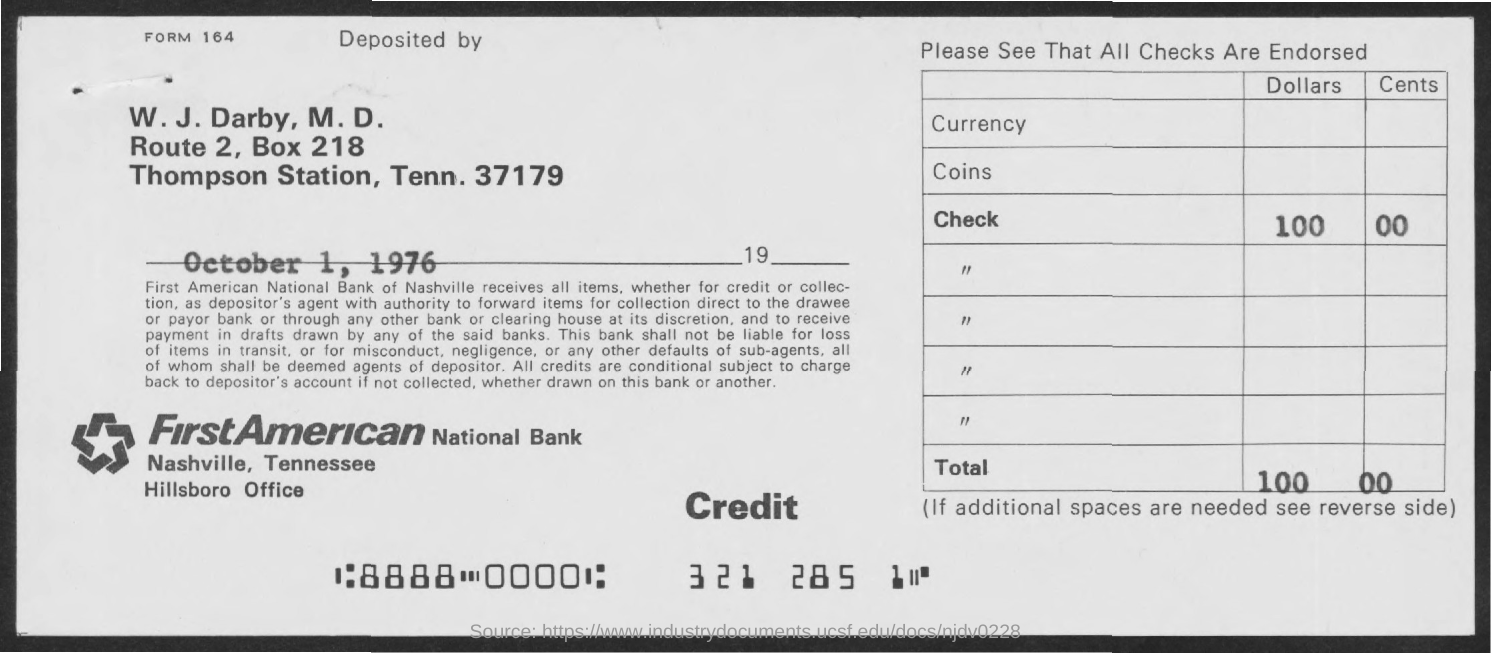Indicate a few pertinent items in this graphic. The memorandum is dated October 1, 1976. The BOX number is 218. 